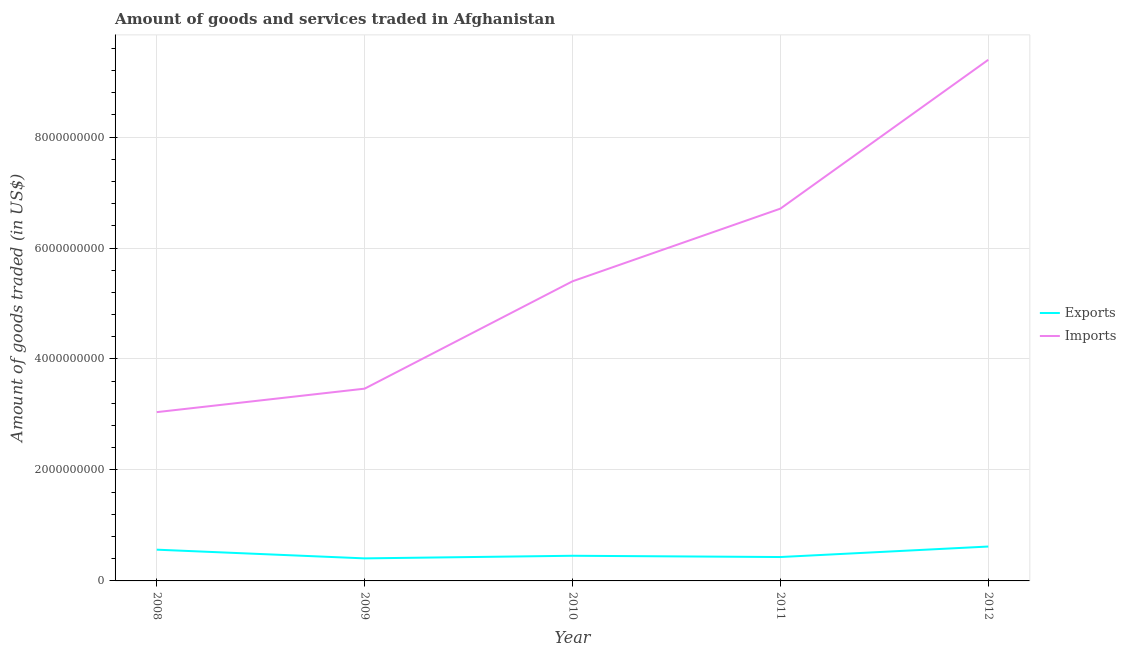How many different coloured lines are there?
Your response must be concise. 2. Does the line corresponding to amount of goods exported intersect with the line corresponding to amount of goods imported?
Ensure brevity in your answer.  No. Is the number of lines equal to the number of legend labels?
Your answer should be very brief. Yes. What is the amount of goods imported in 2011?
Provide a short and direct response. 6.71e+09. Across all years, what is the maximum amount of goods imported?
Provide a succinct answer. 9.39e+09. Across all years, what is the minimum amount of goods exported?
Offer a terse response. 4.06e+08. In which year was the amount of goods imported maximum?
Offer a terse response. 2012. In which year was the amount of goods imported minimum?
Provide a succinct answer. 2008. What is the total amount of goods imported in the graph?
Provide a short and direct response. 2.80e+1. What is the difference between the amount of goods exported in 2008 and that in 2012?
Your response must be concise. -5.67e+07. What is the difference between the amount of goods imported in 2010 and the amount of goods exported in 2009?
Your answer should be compact. 4.99e+09. What is the average amount of goods exported per year?
Keep it short and to the point. 4.95e+08. In the year 2012, what is the difference between the amount of goods imported and amount of goods exported?
Give a very brief answer. 8.77e+09. What is the ratio of the amount of goods imported in 2010 to that in 2012?
Ensure brevity in your answer.  0.57. Is the difference between the amount of goods imported in 2008 and 2010 greater than the difference between the amount of goods exported in 2008 and 2010?
Make the answer very short. No. What is the difference between the highest and the second highest amount of goods imported?
Offer a terse response. 2.68e+09. What is the difference between the highest and the lowest amount of goods imported?
Offer a very short reply. 6.35e+09. In how many years, is the amount of goods imported greater than the average amount of goods imported taken over all years?
Make the answer very short. 2. Does the amount of goods exported monotonically increase over the years?
Give a very brief answer. No. Is the amount of goods imported strictly less than the amount of goods exported over the years?
Give a very brief answer. No. How many lines are there?
Ensure brevity in your answer.  2. What is the difference between two consecutive major ticks on the Y-axis?
Offer a terse response. 2.00e+09. Does the graph contain any zero values?
Your response must be concise. No. Does the graph contain grids?
Your answer should be very brief. Yes. How are the legend labels stacked?
Your answer should be compact. Vertical. What is the title of the graph?
Provide a succinct answer. Amount of goods and services traded in Afghanistan. What is the label or title of the X-axis?
Offer a terse response. Year. What is the label or title of the Y-axis?
Your answer should be compact. Amount of goods traded (in US$). What is the Amount of goods traded (in US$) of Exports in 2008?
Keep it short and to the point. 5.63e+08. What is the Amount of goods traded (in US$) of Imports in 2008?
Give a very brief answer. 3.04e+09. What is the Amount of goods traded (in US$) in Exports in 2009?
Your answer should be compact. 4.06e+08. What is the Amount of goods traded (in US$) in Imports in 2009?
Offer a very short reply. 3.47e+09. What is the Amount of goods traded (in US$) in Exports in 2010?
Provide a succinct answer. 4.53e+08. What is the Amount of goods traded (in US$) of Imports in 2010?
Keep it short and to the point. 5.40e+09. What is the Amount of goods traded (in US$) of Exports in 2011?
Give a very brief answer. 4.31e+08. What is the Amount of goods traded (in US$) in Imports in 2011?
Provide a succinct answer. 6.71e+09. What is the Amount of goods traded (in US$) of Exports in 2012?
Provide a succinct answer. 6.20e+08. What is the Amount of goods traded (in US$) in Imports in 2012?
Give a very brief answer. 9.39e+09. Across all years, what is the maximum Amount of goods traded (in US$) in Exports?
Your response must be concise. 6.20e+08. Across all years, what is the maximum Amount of goods traded (in US$) in Imports?
Keep it short and to the point. 9.39e+09. Across all years, what is the minimum Amount of goods traded (in US$) of Exports?
Offer a very short reply. 4.06e+08. Across all years, what is the minimum Amount of goods traded (in US$) in Imports?
Make the answer very short. 3.04e+09. What is the total Amount of goods traded (in US$) of Exports in the graph?
Your answer should be compact. 2.47e+09. What is the total Amount of goods traded (in US$) of Imports in the graph?
Keep it short and to the point. 2.80e+1. What is the difference between the Amount of goods traded (in US$) of Exports in 2008 and that in 2009?
Ensure brevity in your answer.  1.57e+08. What is the difference between the Amount of goods traded (in US$) in Imports in 2008 and that in 2009?
Your answer should be very brief. -4.23e+08. What is the difference between the Amount of goods traded (in US$) of Exports in 2008 and that in 2010?
Give a very brief answer. 1.10e+08. What is the difference between the Amount of goods traded (in US$) in Imports in 2008 and that in 2010?
Provide a short and direct response. -2.36e+09. What is the difference between the Amount of goods traded (in US$) of Exports in 2008 and that in 2011?
Offer a terse response. 1.32e+08. What is the difference between the Amount of goods traded (in US$) in Imports in 2008 and that in 2011?
Give a very brief answer. -3.67e+09. What is the difference between the Amount of goods traded (in US$) in Exports in 2008 and that in 2012?
Make the answer very short. -5.67e+07. What is the difference between the Amount of goods traded (in US$) in Imports in 2008 and that in 2012?
Keep it short and to the point. -6.35e+09. What is the difference between the Amount of goods traded (in US$) in Exports in 2009 and that in 2010?
Offer a terse response. -4.72e+07. What is the difference between the Amount of goods traded (in US$) of Imports in 2009 and that in 2010?
Your response must be concise. -1.94e+09. What is the difference between the Amount of goods traded (in US$) of Exports in 2009 and that in 2011?
Your answer should be compact. -2.45e+07. What is the difference between the Amount of goods traded (in US$) in Imports in 2009 and that in 2011?
Your answer should be compact. -3.24e+09. What is the difference between the Amount of goods traded (in US$) in Exports in 2009 and that in 2012?
Provide a short and direct response. -2.14e+08. What is the difference between the Amount of goods traded (in US$) in Imports in 2009 and that in 2012?
Make the answer very short. -5.93e+09. What is the difference between the Amount of goods traded (in US$) in Exports in 2010 and that in 2011?
Offer a very short reply. 2.27e+07. What is the difference between the Amount of goods traded (in US$) of Imports in 2010 and that in 2011?
Ensure brevity in your answer.  -1.31e+09. What is the difference between the Amount of goods traded (in US$) in Exports in 2010 and that in 2012?
Offer a very short reply. -1.66e+08. What is the difference between the Amount of goods traded (in US$) in Imports in 2010 and that in 2012?
Make the answer very short. -3.99e+09. What is the difference between the Amount of goods traded (in US$) in Exports in 2011 and that in 2012?
Your answer should be very brief. -1.89e+08. What is the difference between the Amount of goods traded (in US$) of Imports in 2011 and that in 2012?
Your answer should be very brief. -2.68e+09. What is the difference between the Amount of goods traded (in US$) of Exports in 2008 and the Amount of goods traded (in US$) of Imports in 2009?
Ensure brevity in your answer.  -2.90e+09. What is the difference between the Amount of goods traded (in US$) in Exports in 2008 and the Amount of goods traded (in US$) in Imports in 2010?
Ensure brevity in your answer.  -4.84e+09. What is the difference between the Amount of goods traded (in US$) in Exports in 2008 and the Amount of goods traded (in US$) in Imports in 2011?
Keep it short and to the point. -6.15e+09. What is the difference between the Amount of goods traded (in US$) of Exports in 2008 and the Amount of goods traded (in US$) of Imports in 2012?
Keep it short and to the point. -8.83e+09. What is the difference between the Amount of goods traded (in US$) of Exports in 2009 and the Amount of goods traded (in US$) of Imports in 2010?
Ensure brevity in your answer.  -4.99e+09. What is the difference between the Amount of goods traded (in US$) of Exports in 2009 and the Amount of goods traded (in US$) of Imports in 2011?
Provide a succinct answer. -6.30e+09. What is the difference between the Amount of goods traded (in US$) in Exports in 2009 and the Amount of goods traded (in US$) in Imports in 2012?
Your answer should be compact. -8.99e+09. What is the difference between the Amount of goods traded (in US$) in Exports in 2010 and the Amount of goods traded (in US$) in Imports in 2011?
Your answer should be very brief. -6.26e+09. What is the difference between the Amount of goods traded (in US$) in Exports in 2010 and the Amount of goods traded (in US$) in Imports in 2012?
Give a very brief answer. -8.94e+09. What is the difference between the Amount of goods traded (in US$) of Exports in 2011 and the Amount of goods traded (in US$) of Imports in 2012?
Keep it short and to the point. -8.96e+09. What is the average Amount of goods traded (in US$) of Exports per year?
Keep it short and to the point. 4.95e+08. What is the average Amount of goods traded (in US$) in Imports per year?
Make the answer very short. 5.60e+09. In the year 2008, what is the difference between the Amount of goods traded (in US$) in Exports and Amount of goods traded (in US$) in Imports?
Your response must be concise. -2.48e+09. In the year 2009, what is the difference between the Amount of goods traded (in US$) in Exports and Amount of goods traded (in US$) in Imports?
Offer a very short reply. -3.06e+09. In the year 2010, what is the difference between the Amount of goods traded (in US$) of Exports and Amount of goods traded (in US$) of Imports?
Provide a succinct answer. -4.95e+09. In the year 2011, what is the difference between the Amount of goods traded (in US$) of Exports and Amount of goods traded (in US$) of Imports?
Provide a succinct answer. -6.28e+09. In the year 2012, what is the difference between the Amount of goods traded (in US$) of Exports and Amount of goods traded (in US$) of Imports?
Ensure brevity in your answer.  -8.77e+09. What is the ratio of the Amount of goods traded (in US$) of Exports in 2008 to that in 2009?
Ensure brevity in your answer.  1.39. What is the ratio of the Amount of goods traded (in US$) in Imports in 2008 to that in 2009?
Your answer should be very brief. 0.88. What is the ratio of the Amount of goods traded (in US$) in Exports in 2008 to that in 2010?
Your answer should be compact. 1.24. What is the ratio of the Amount of goods traded (in US$) of Imports in 2008 to that in 2010?
Your answer should be compact. 0.56. What is the ratio of the Amount of goods traded (in US$) in Exports in 2008 to that in 2011?
Provide a short and direct response. 1.31. What is the ratio of the Amount of goods traded (in US$) in Imports in 2008 to that in 2011?
Offer a very short reply. 0.45. What is the ratio of the Amount of goods traded (in US$) of Exports in 2008 to that in 2012?
Provide a succinct answer. 0.91. What is the ratio of the Amount of goods traded (in US$) of Imports in 2008 to that in 2012?
Keep it short and to the point. 0.32. What is the ratio of the Amount of goods traded (in US$) in Exports in 2009 to that in 2010?
Your response must be concise. 0.9. What is the ratio of the Amount of goods traded (in US$) of Imports in 2009 to that in 2010?
Give a very brief answer. 0.64. What is the ratio of the Amount of goods traded (in US$) of Exports in 2009 to that in 2011?
Your answer should be compact. 0.94. What is the ratio of the Amount of goods traded (in US$) of Imports in 2009 to that in 2011?
Your answer should be very brief. 0.52. What is the ratio of the Amount of goods traded (in US$) of Exports in 2009 to that in 2012?
Make the answer very short. 0.66. What is the ratio of the Amount of goods traded (in US$) of Imports in 2009 to that in 2012?
Offer a very short reply. 0.37. What is the ratio of the Amount of goods traded (in US$) in Exports in 2010 to that in 2011?
Make the answer very short. 1.05. What is the ratio of the Amount of goods traded (in US$) of Imports in 2010 to that in 2011?
Provide a succinct answer. 0.8. What is the ratio of the Amount of goods traded (in US$) in Exports in 2010 to that in 2012?
Your answer should be compact. 0.73. What is the ratio of the Amount of goods traded (in US$) in Imports in 2010 to that in 2012?
Make the answer very short. 0.57. What is the ratio of the Amount of goods traded (in US$) of Exports in 2011 to that in 2012?
Ensure brevity in your answer.  0.69. What is the ratio of the Amount of goods traded (in US$) of Imports in 2011 to that in 2012?
Your answer should be compact. 0.71. What is the difference between the highest and the second highest Amount of goods traded (in US$) in Exports?
Your response must be concise. 5.67e+07. What is the difference between the highest and the second highest Amount of goods traded (in US$) of Imports?
Offer a terse response. 2.68e+09. What is the difference between the highest and the lowest Amount of goods traded (in US$) of Exports?
Give a very brief answer. 2.14e+08. What is the difference between the highest and the lowest Amount of goods traded (in US$) of Imports?
Your answer should be very brief. 6.35e+09. 